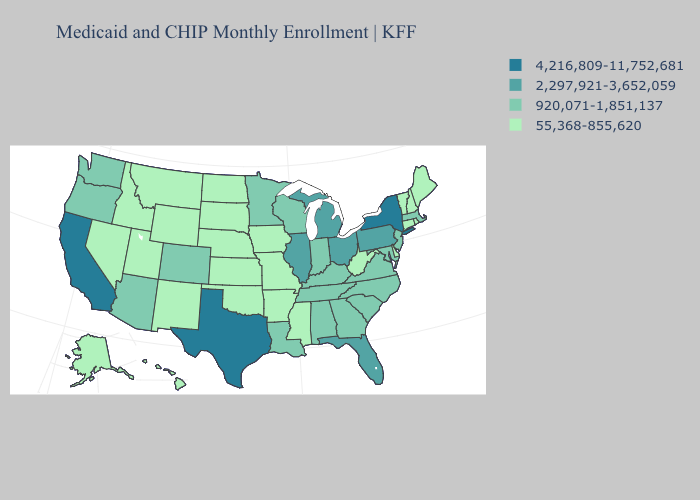Among the states that border Rhode Island , does Connecticut have the highest value?
Write a very short answer. No. Which states hav the highest value in the South?
Quick response, please. Texas. Does Texas have the highest value in the South?
Quick response, please. Yes. Name the states that have a value in the range 55,368-855,620?
Write a very short answer. Alaska, Arkansas, Connecticut, Delaware, Hawaii, Idaho, Iowa, Kansas, Maine, Mississippi, Missouri, Montana, Nebraska, Nevada, New Hampshire, New Mexico, North Dakota, Oklahoma, Rhode Island, South Dakota, Utah, Vermont, West Virginia, Wyoming. Name the states that have a value in the range 4,216,809-11,752,681?
Short answer required. California, New York, Texas. What is the lowest value in the West?
Answer briefly. 55,368-855,620. Does Oklahoma have the lowest value in the South?
Answer briefly. Yes. What is the lowest value in states that border Louisiana?
Be succinct. 55,368-855,620. Among the states that border Arizona , which have the lowest value?
Short answer required. Nevada, New Mexico, Utah. Among the states that border Illinois , which have the lowest value?
Short answer required. Iowa, Missouri. Name the states that have a value in the range 920,071-1,851,137?
Concise answer only. Alabama, Arizona, Colorado, Georgia, Indiana, Kentucky, Louisiana, Maryland, Massachusetts, Minnesota, New Jersey, North Carolina, Oregon, South Carolina, Tennessee, Virginia, Washington, Wisconsin. Name the states that have a value in the range 2,297,921-3,652,059?
Quick response, please. Florida, Illinois, Michigan, Ohio, Pennsylvania. Name the states that have a value in the range 2,297,921-3,652,059?
Short answer required. Florida, Illinois, Michigan, Ohio, Pennsylvania. What is the highest value in the USA?
Short answer required. 4,216,809-11,752,681. Name the states that have a value in the range 4,216,809-11,752,681?
Be succinct. California, New York, Texas. 